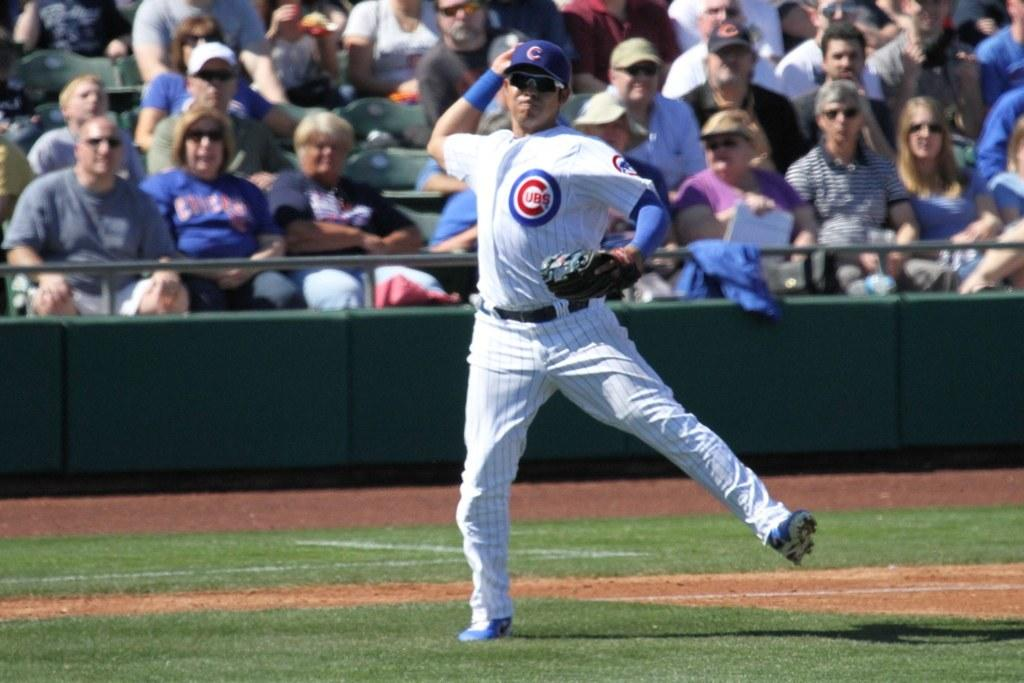<image>
Relay a brief, clear account of the picture shown. a Cubs jersey that is on the player 